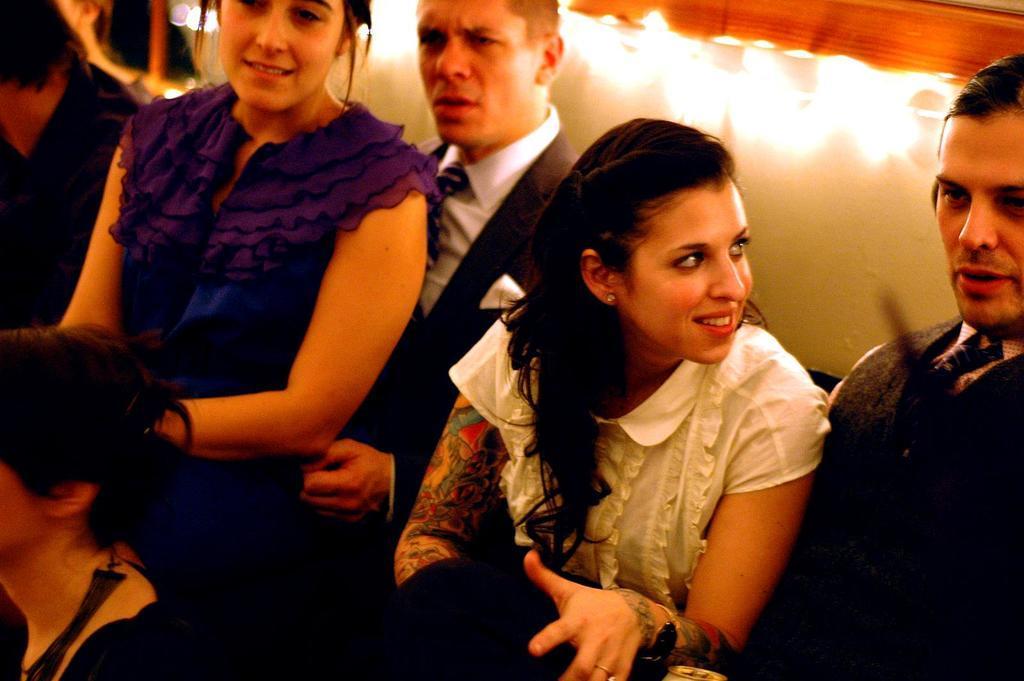How would you summarize this image in a sentence or two? In this image we can see this woman wearing a white dress and having tattoos on her hand is looking at this man who is wearing a blazer and tie. Here we can see this woman wearing a blue dress and we can see this man wearing a blazer, tie and white shirt. In the background, we can see the lights. 